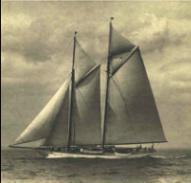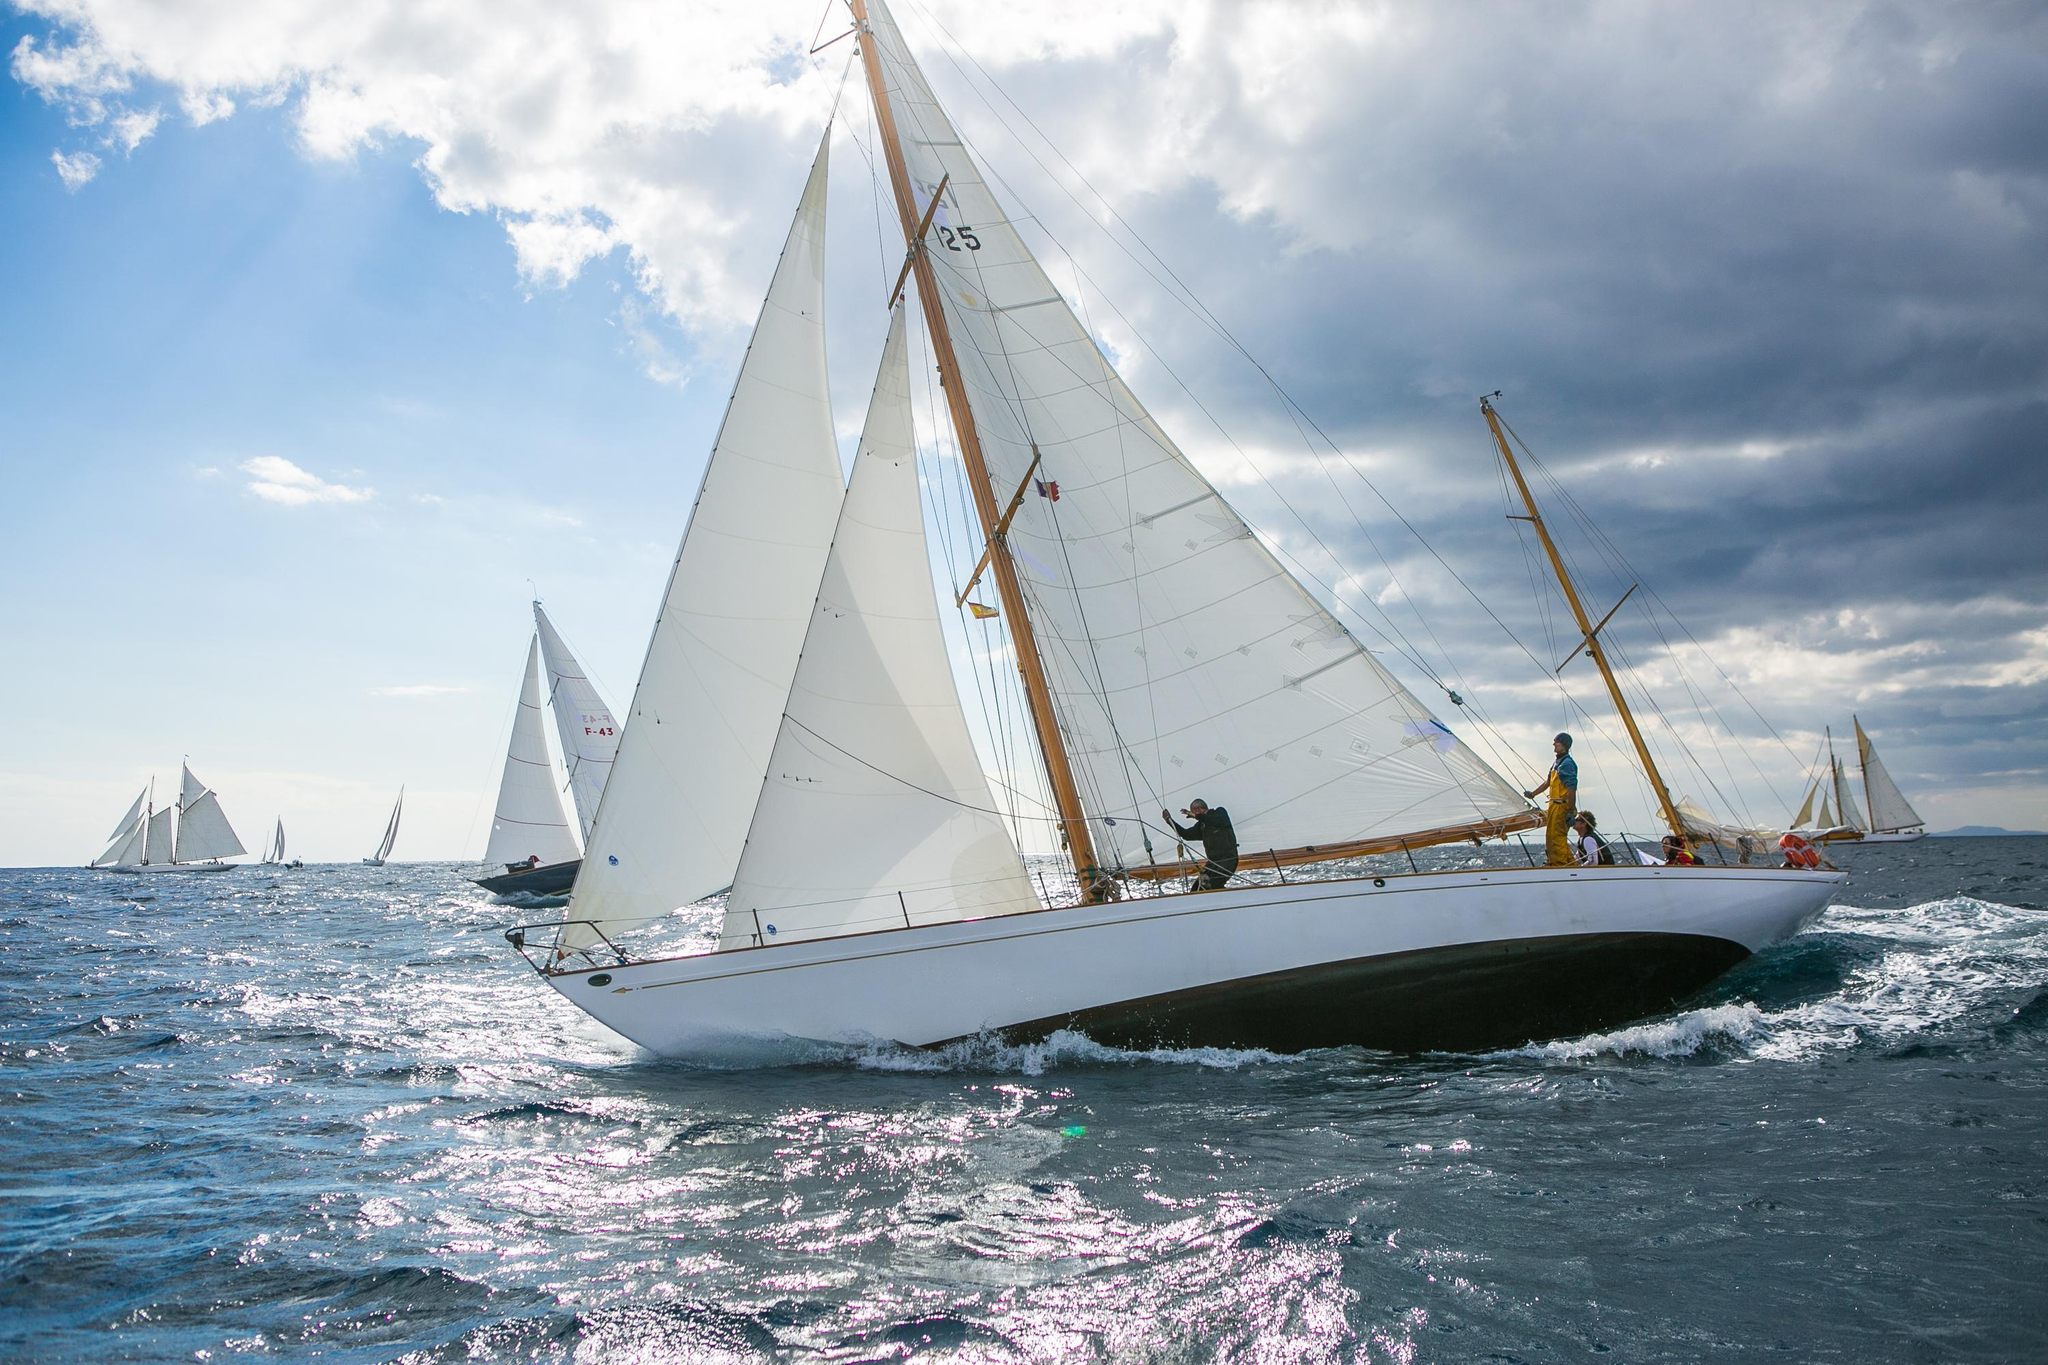The first image is the image on the left, the second image is the image on the right. For the images displayed, is the sentence "An image shows a boat with white sails in a body of blue water." factually correct? Answer yes or no. Yes. The first image is the image on the left, the second image is the image on the right. Assess this claim about the two images: "A few clouds are visible in the picture on the left.". Correct or not? Answer yes or no. Yes. 